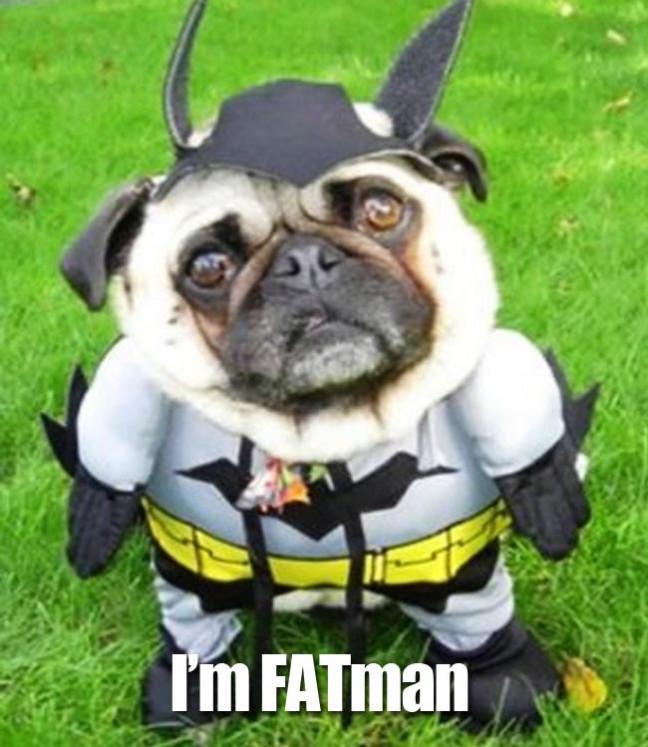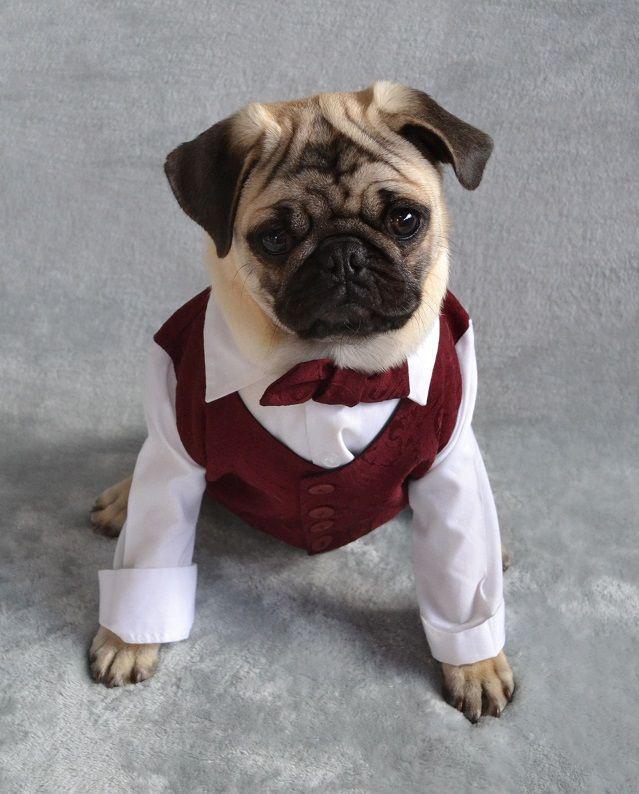The first image is the image on the left, the second image is the image on the right. Given the left and right images, does the statement "There is at least three dogs." hold true? Answer yes or no. No. The first image is the image on the left, the second image is the image on the right. Given the left and right images, does the statement "Each image contains one pug wearing an outfit, including the letfthand dog wearing a grayish and yellow outift, and the righthand dog in formal human-like attire." hold true? Answer yes or no. Yes. 